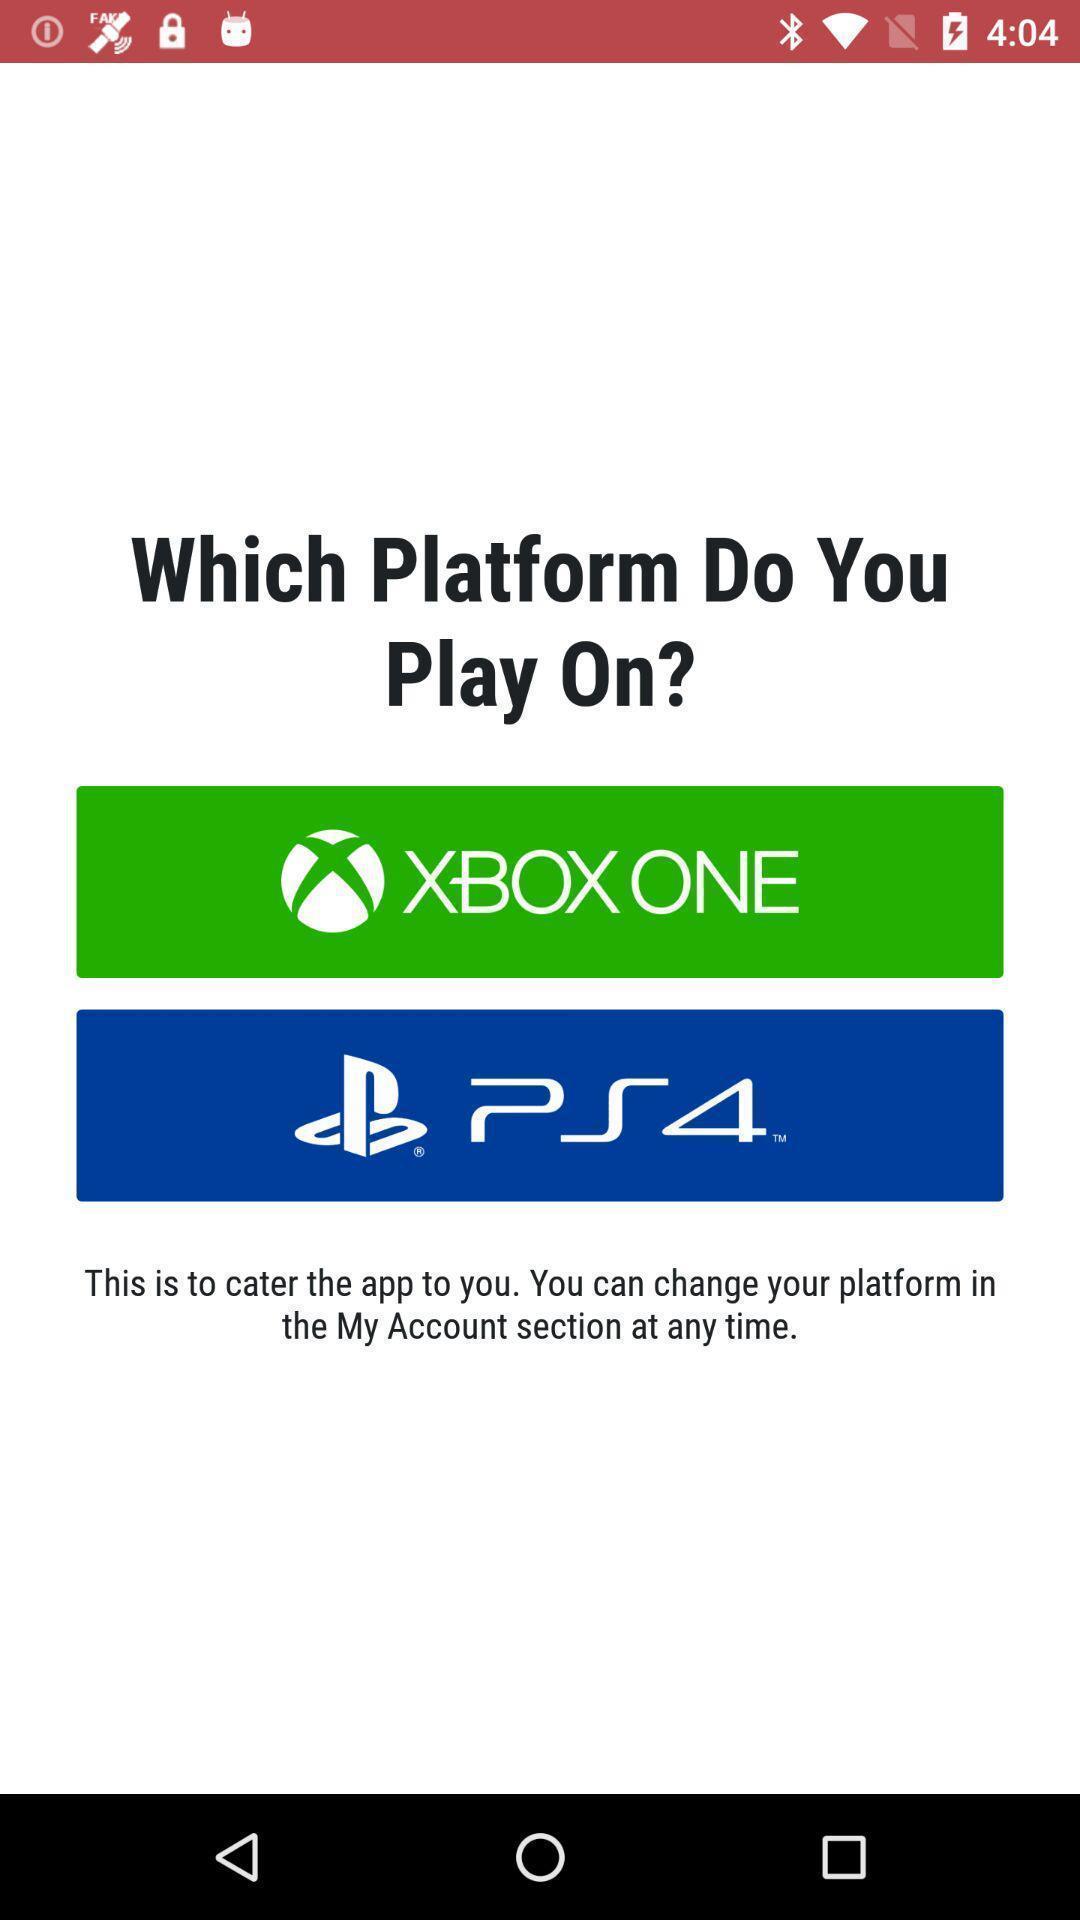Summarize the main components in this picture. Starting page. 